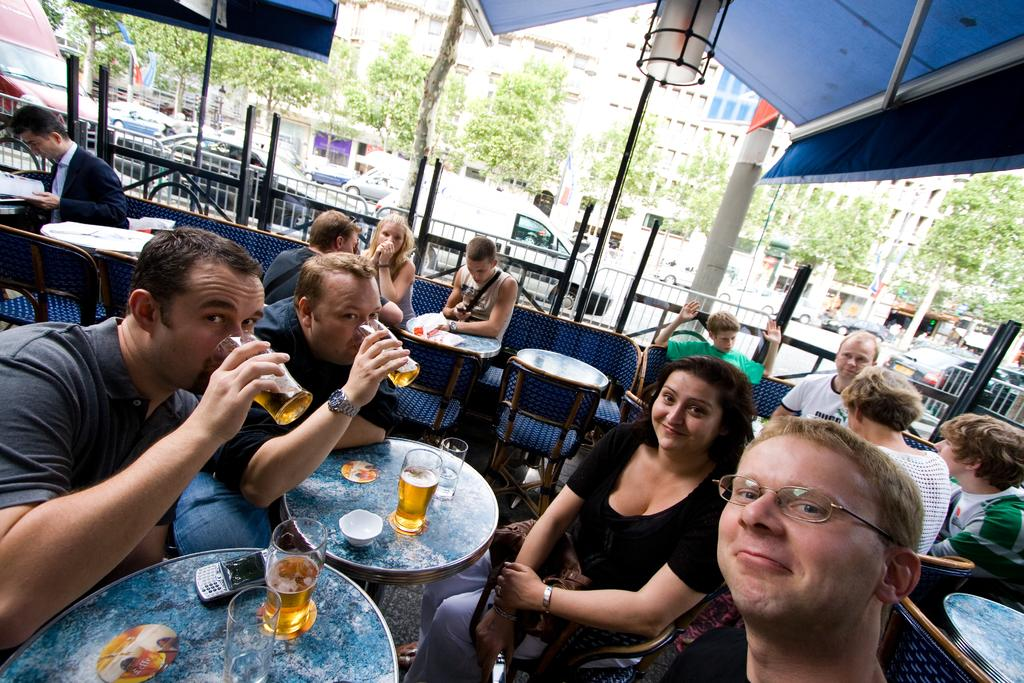What are the persons in the image doing? The persons in the image are sitting on chairs. What are the persons holding in their hands? The persons are holding glasses in their hands. What can be seen in the background of the image? There are trees, vehicles, and buildings in the background of the image. What unit of measurement is used to determine the age of the dad in the image? There is no dad present in the image, and therefore no age to measure. What date is circled on the calendar in the image? There is no calendar present in the image. 